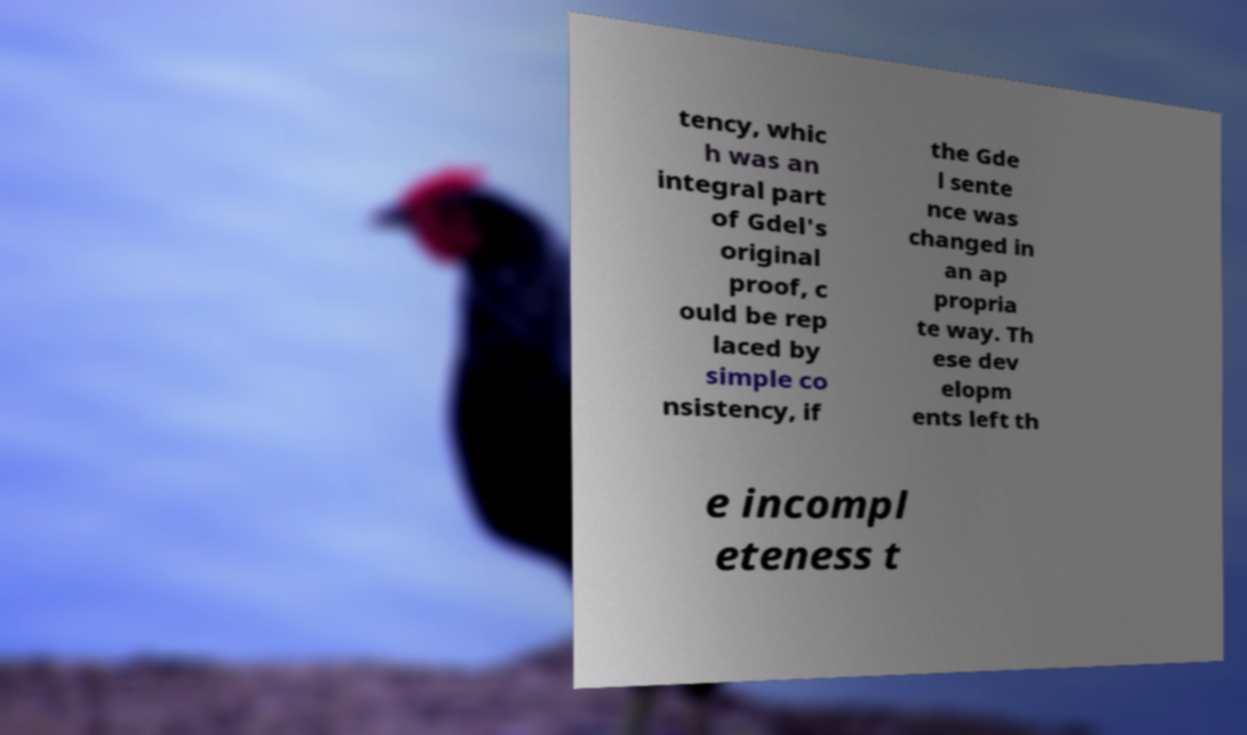Please identify and transcribe the text found in this image. tency, whic h was an integral part of Gdel's original proof, c ould be rep laced by simple co nsistency, if the Gde l sente nce was changed in an ap propria te way. Th ese dev elopm ents left th e incompl eteness t 